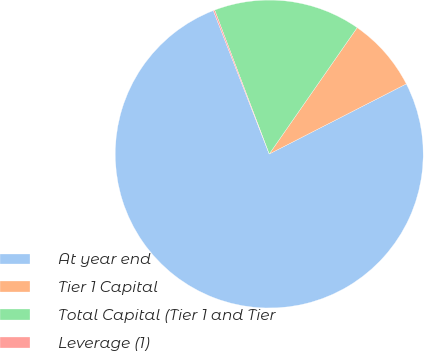Convert chart. <chart><loc_0><loc_0><loc_500><loc_500><pie_chart><fcel>At year end<fcel>Tier 1 Capital<fcel>Total Capital (Tier 1 and Tier<fcel>Leverage (1)<nl><fcel>76.6%<fcel>7.8%<fcel>15.44%<fcel>0.15%<nl></chart> 